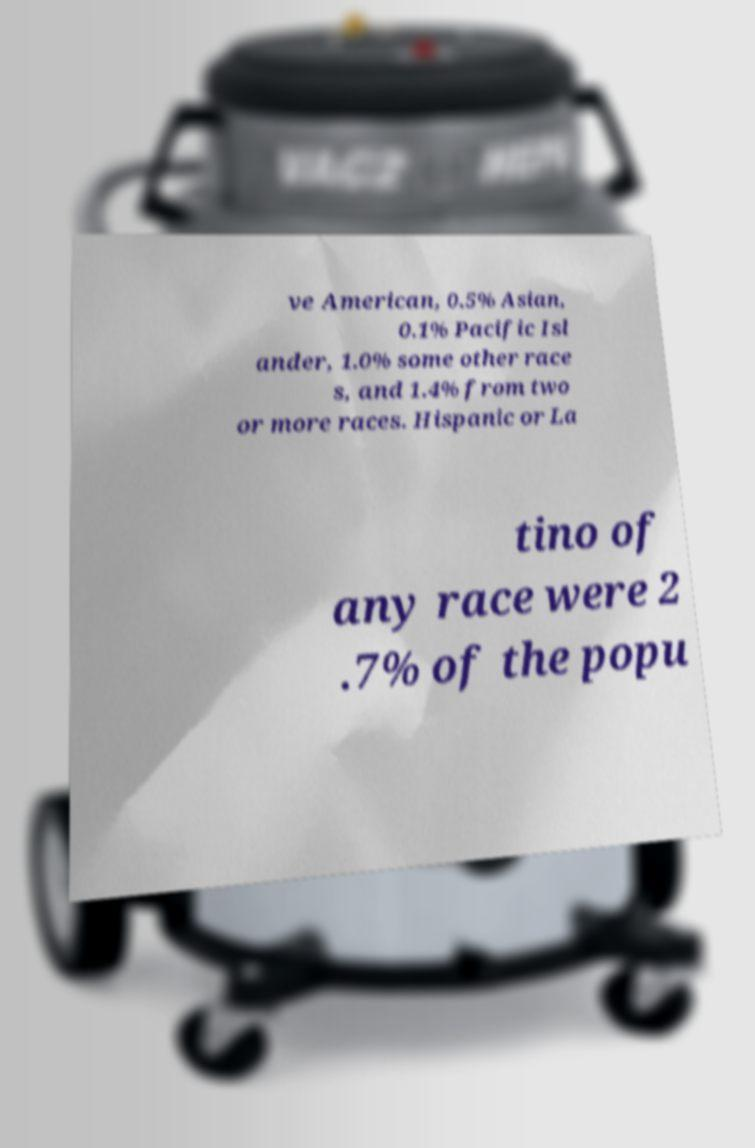Please identify and transcribe the text found in this image. ve American, 0.5% Asian, 0.1% Pacific Isl ander, 1.0% some other race s, and 1.4% from two or more races. Hispanic or La tino of any race were 2 .7% of the popu 